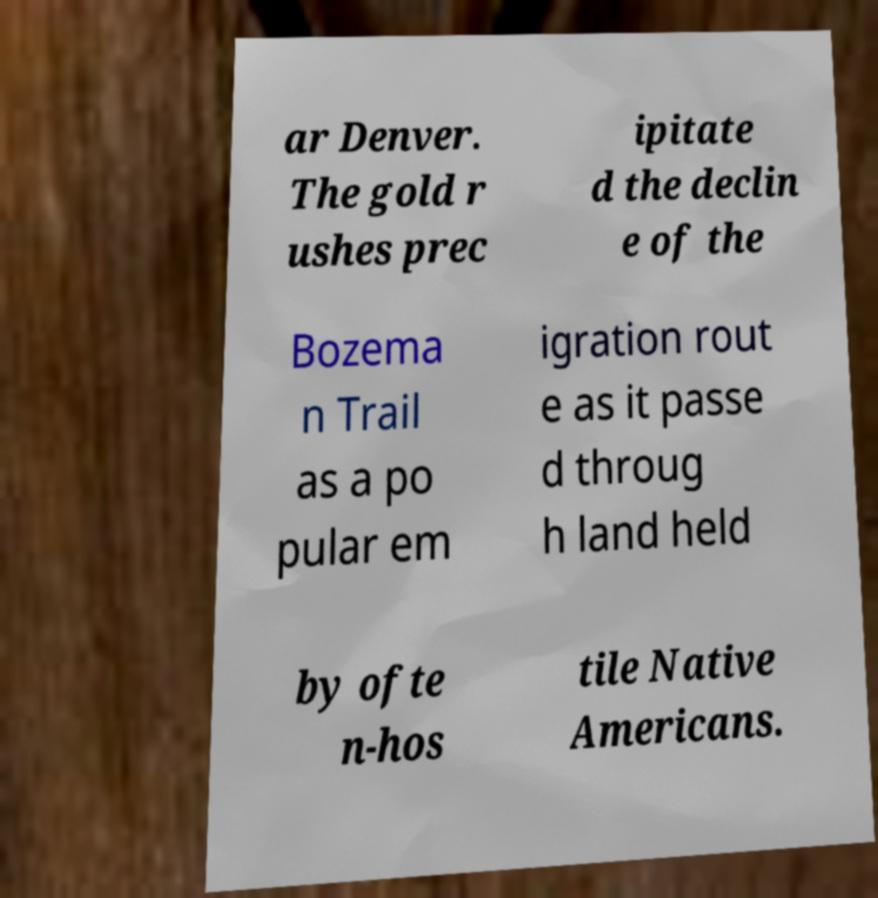I need the written content from this picture converted into text. Can you do that? ar Denver. The gold r ushes prec ipitate d the declin e of the Bozema n Trail as a po pular em igration rout e as it passe d throug h land held by ofte n-hos tile Native Americans. 